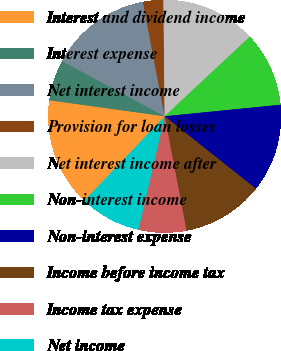Convert chart. <chart><loc_0><loc_0><loc_500><loc_500><pie_chart><fcel>Interest and dividend income<fcel>Interest expense<fcel>Net interest income<fcel>Provision for loan losses<fcel>Net interest income after<fcel>Non-interest income<fcel>Non-interest expense<fcel>Income before income tax<fcel>Income tax expense<fcel>Net income<nl><fcel>15.09%<fcel>5.66%<fcel>14.15%<fcel>2.83%<fcel>13.21%<fcel>10.38%<fcel>12.26%<fcel>11.32%<fcel>6.61%<fcel>8.49%<nl></chart> 